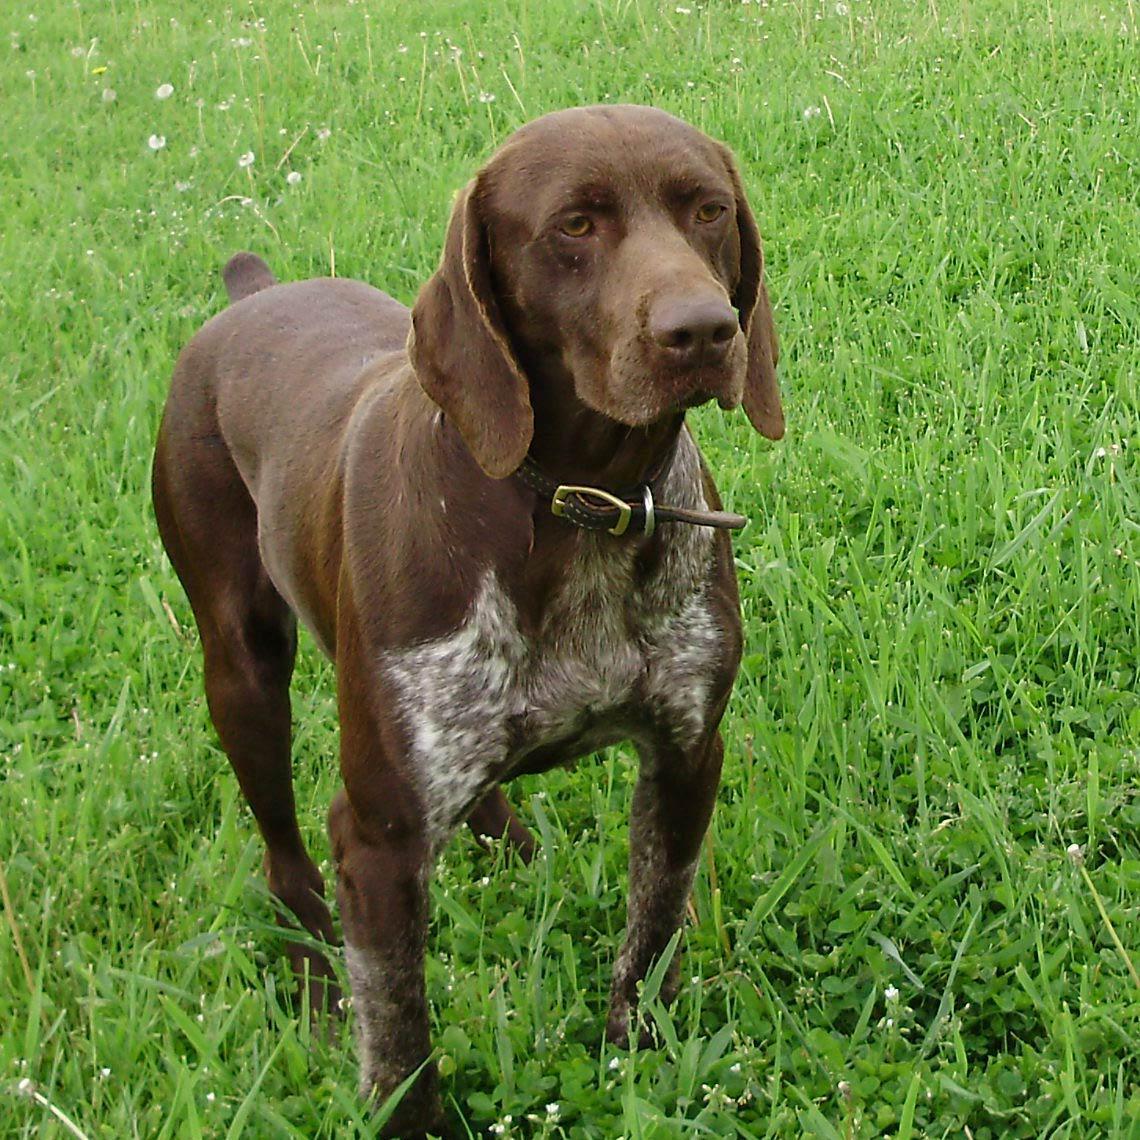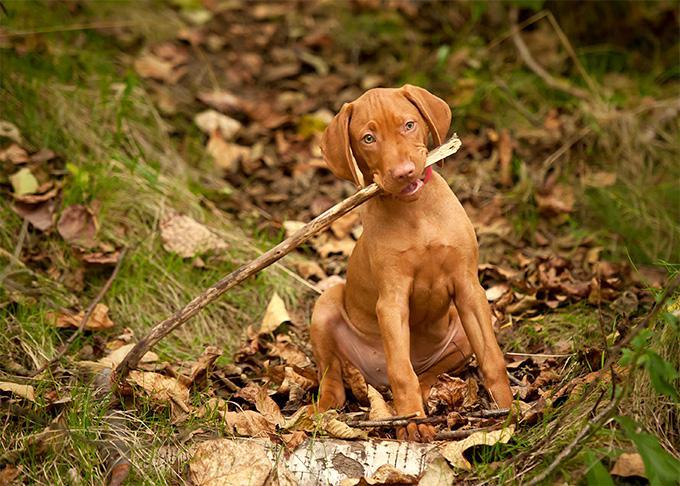The first image is the image on the left, the second image is the image on the right. Considering the images on both sides, is "The dog in the image on the left is wearing a collar." valid? Answer yes or no. Yes. 